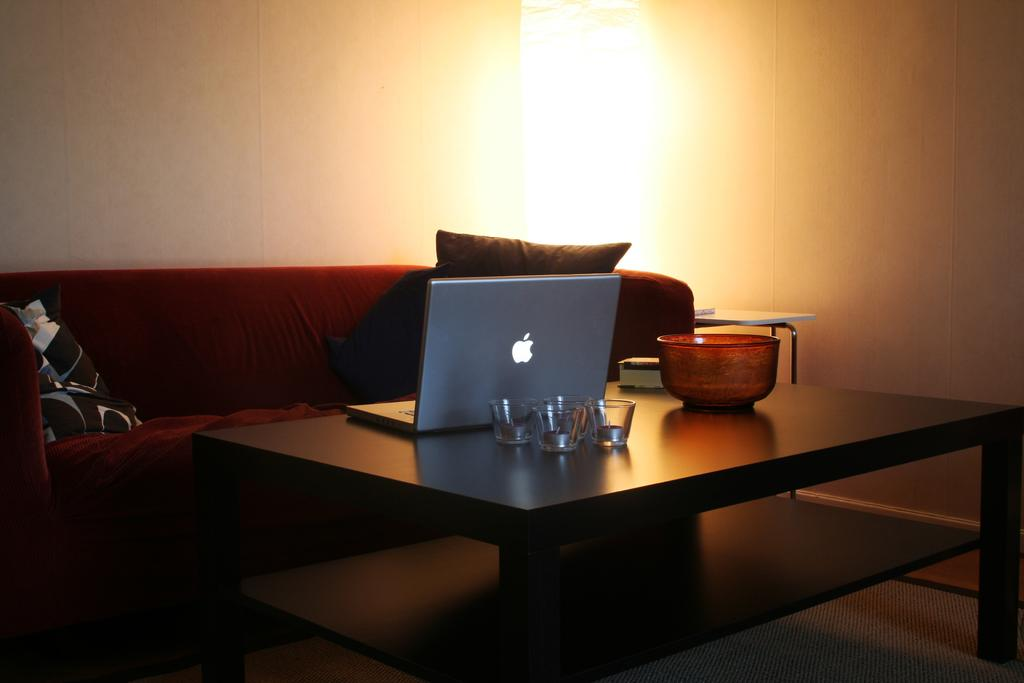What type of furniture is in the image? There is a table and a red colored couch in the image. What is on the table in the image? A laptop, small glasses, and a bowl are on the table in the image. What is attached to the wall in the image? There is a lamp attached to the wall in the image. How is the couch in the image? The couch has cushions. How many writers are sleeping on the couch in the image? There are no writers or sleeping individuals present in the image. 